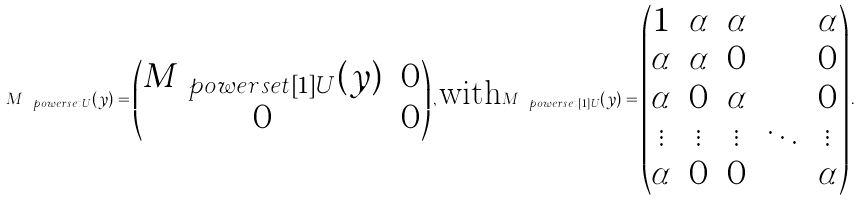<formula> <loc_0><loc_0><loc_500><loc_500>M _ { \ p o w e r s e t { U } } ( y ) = \begin{pmatrix} M _ { \ p o w e r s e t [ 1 ] { U } } ( y ) & 0 \\ 0 & 0 \end{pmatrix} , \text {with} M _ { \ p o w e r s e t [ 1 ] { U } } ( y ) = \begin{pmatrix} 1 & \alpha & \alpha & \cdots & \alpha \\ \alpha & \alpha & 0 & \cdots & 0 \\ \alpha & 0 & \alpha & \cdots & 0 \\ \vdots & \vdots & \vdots & \ddots & \vdots \\ \alpha & 0 & 0 & \cdots & \alpha \end{pmatrix} .</formula> 